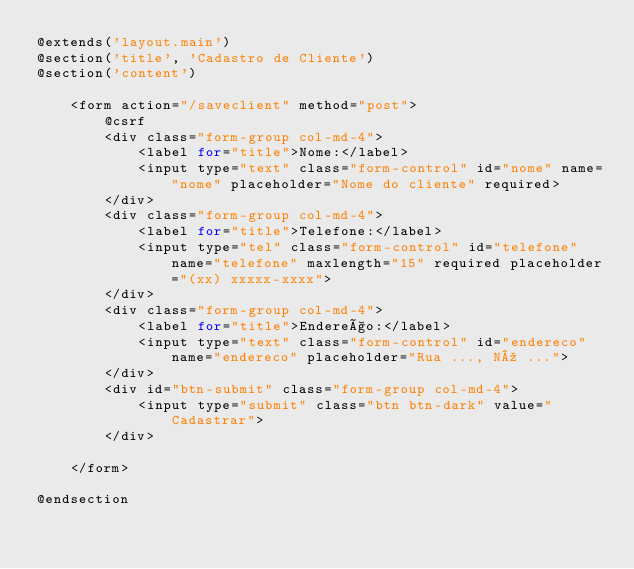<code> <loc_0><loc_0><loc_500><loc_500><_PHP_>@extends('layout.main')
@section('title', 'Cadastro de Cliente')
@section('content')

    <form action="/saveclient" method="post">
        @csrf
        <div class="form-group col-md-4">
            <label for="title">Nome:</label>
            <input type="text" class="form-control" id="nome" name="nome" placeholder="Nome do cliente" required>
        </div>
        <div class="form-group col-md-4">
            <label for="title">Telefone:</label>
            <input type="tel" class="form-control" id="telefone" name="telefone" maxlength="15" required placeholder="(xx) xxxxx-xxxx">
        </div>
        <div class="form-group col-md-4">
            <label for="title">Endereço:</label>
            <input type="text" class="form-control" id="endereco" name="endereco" placeholder="Rua ..., Nº ...">
        </div>
        <div id="btn-submit" class="form-group col-md-4">
            <input type="submit" class="btn btn-dark" value="Cadastrar">
        </div>

    </form>

@endsection
</code> 